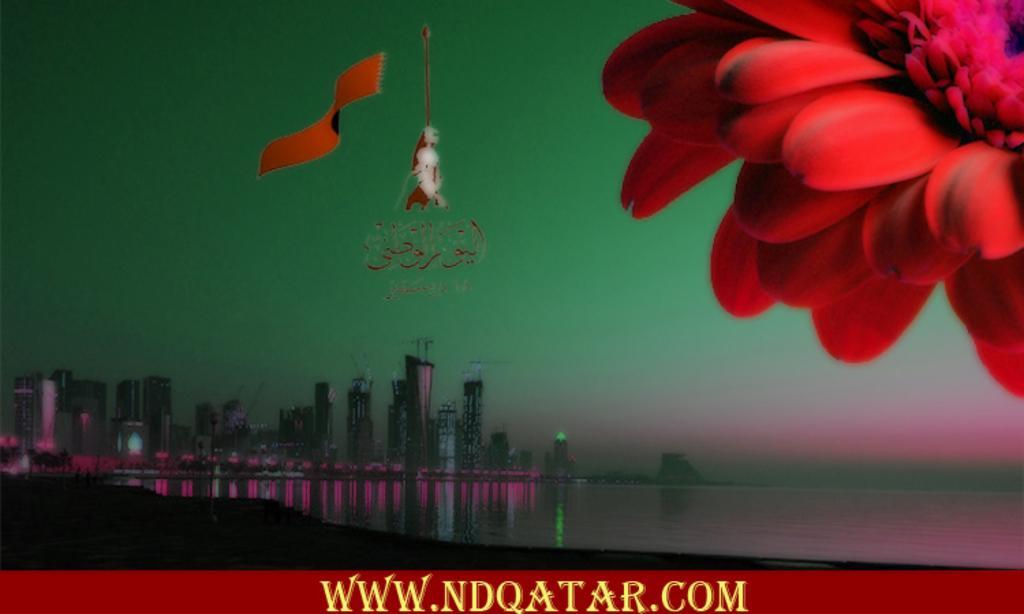Please provide a concise description of this image. In this image we can see an ocean and buildings. Top right of the image one red color flower is there, bottom watermark is present. 